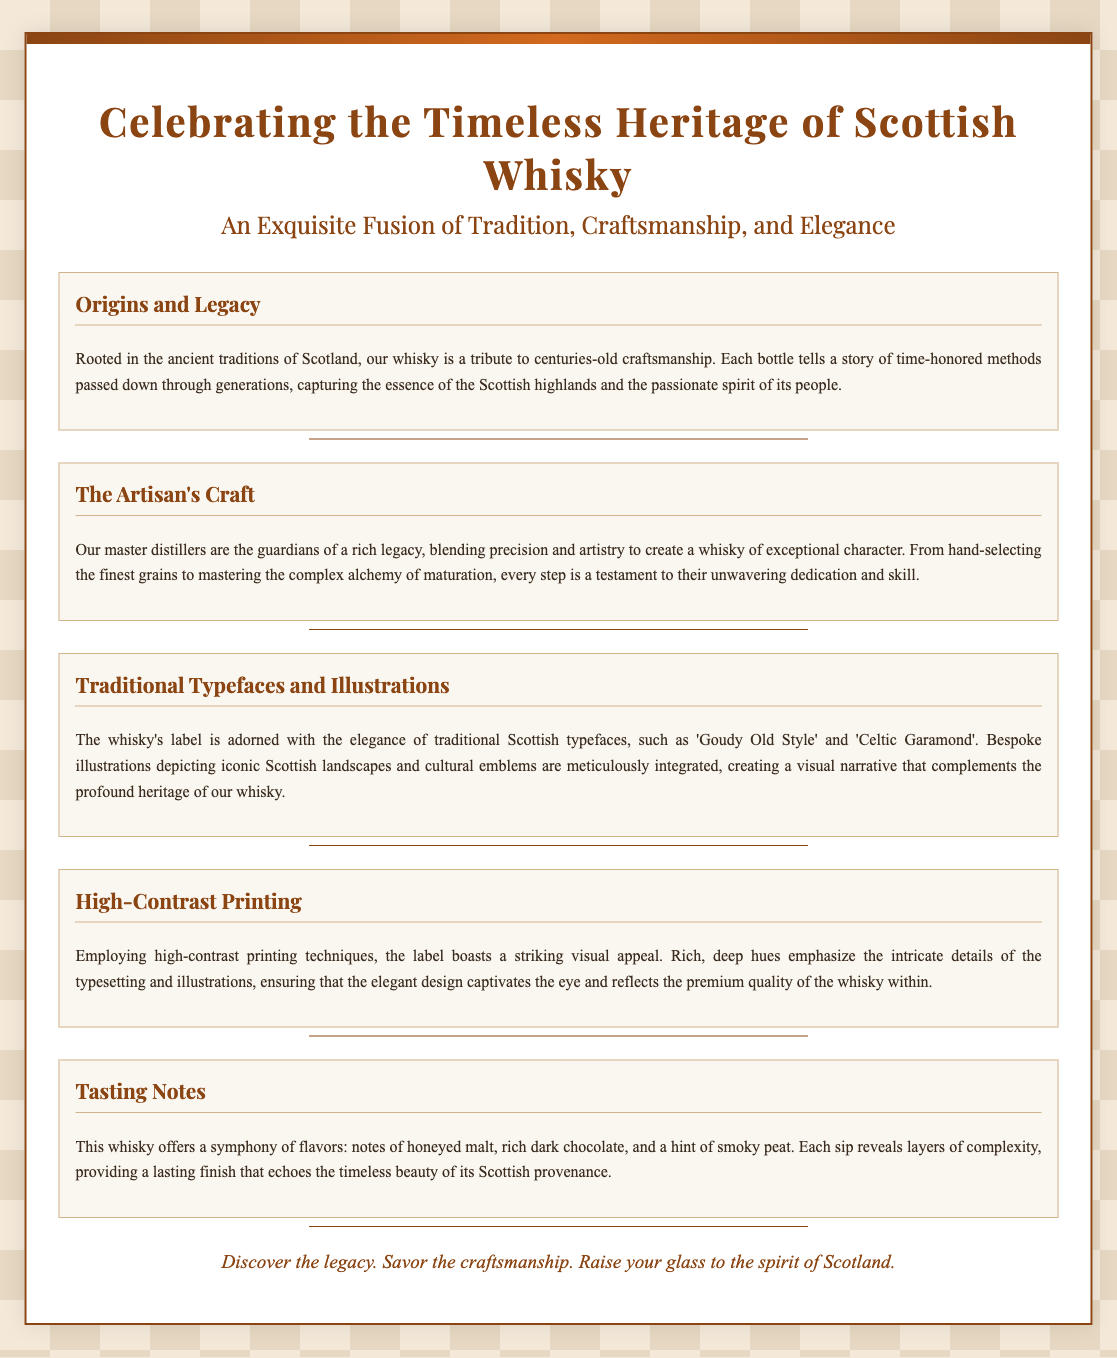What is the title of the promotion? The title of the promotion is prominently displayed at the top of the document.
Answer: Celebrating the Timeless Heritage of Scottish Whisky What typefaces are mentioned in the document? The document specifically mentions certain typefaces used in the label design.
Answer: Goudy Old Style, Celtic Garamond How many sections are there in the document? The document lists various sections, and counting them gives the total.
Answer: Five What are the key flavors noted in the tasting notes? The tasting notes describe several flavors present in the whisky.
Answer: Honeyed malt, rich dark chocolate, smoky peat What visual technique is used to enhance the label? The document describes a method used to create striking visuals on the label.
Answer: High-contrast printing Who are the guardians of the whisky's legacy? The document refers to a specific group responsible for crafting the whisky.
Answer: Master distillers What does the document suggest about the artisans' approach? The document indicates the artisans' dedication to their craft through certain actions.
Answer: Blending precision and artistry What is the color scheme of the body background? The document describes the colors that make up the body background.
Answer: Pale beige 